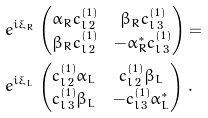<formula> <loc_0><loc_0><loc_500><loc_500>& e ^ { i \xi _ { R } } \begin{pmatrix} \alpha _ { R } c ^ { ( 1 ) } _ { l \, 2 } & \beta _ { R } c ^ { ( 1 ) } _ { l \, 3 } \\ \beta _ { R } c ^ { ( 1 ) } _ { l \, 2 } & - \alpha _ { R } ^ { \ast } c ^ { ( 1 ) } _ { l \, 3 } \end{pmatrix} = \\ & e ^ { i \xi _ { L } } \begin{pmatrix} c ^ { ( 1 ) } _ { l \, 2 } \alpha _ { L } & c ^ { ( 1 ) } _ { l \, 2 } \beta _ { L } \\ c ^ { ( 1 ) } _ { l \, 3 } \beta _ { L } & - c ^ { ( 1 ) } _ { l \, 3 } \alpha _ { L } ^ { \ast } \end{pmatrix} \, .</formula> 